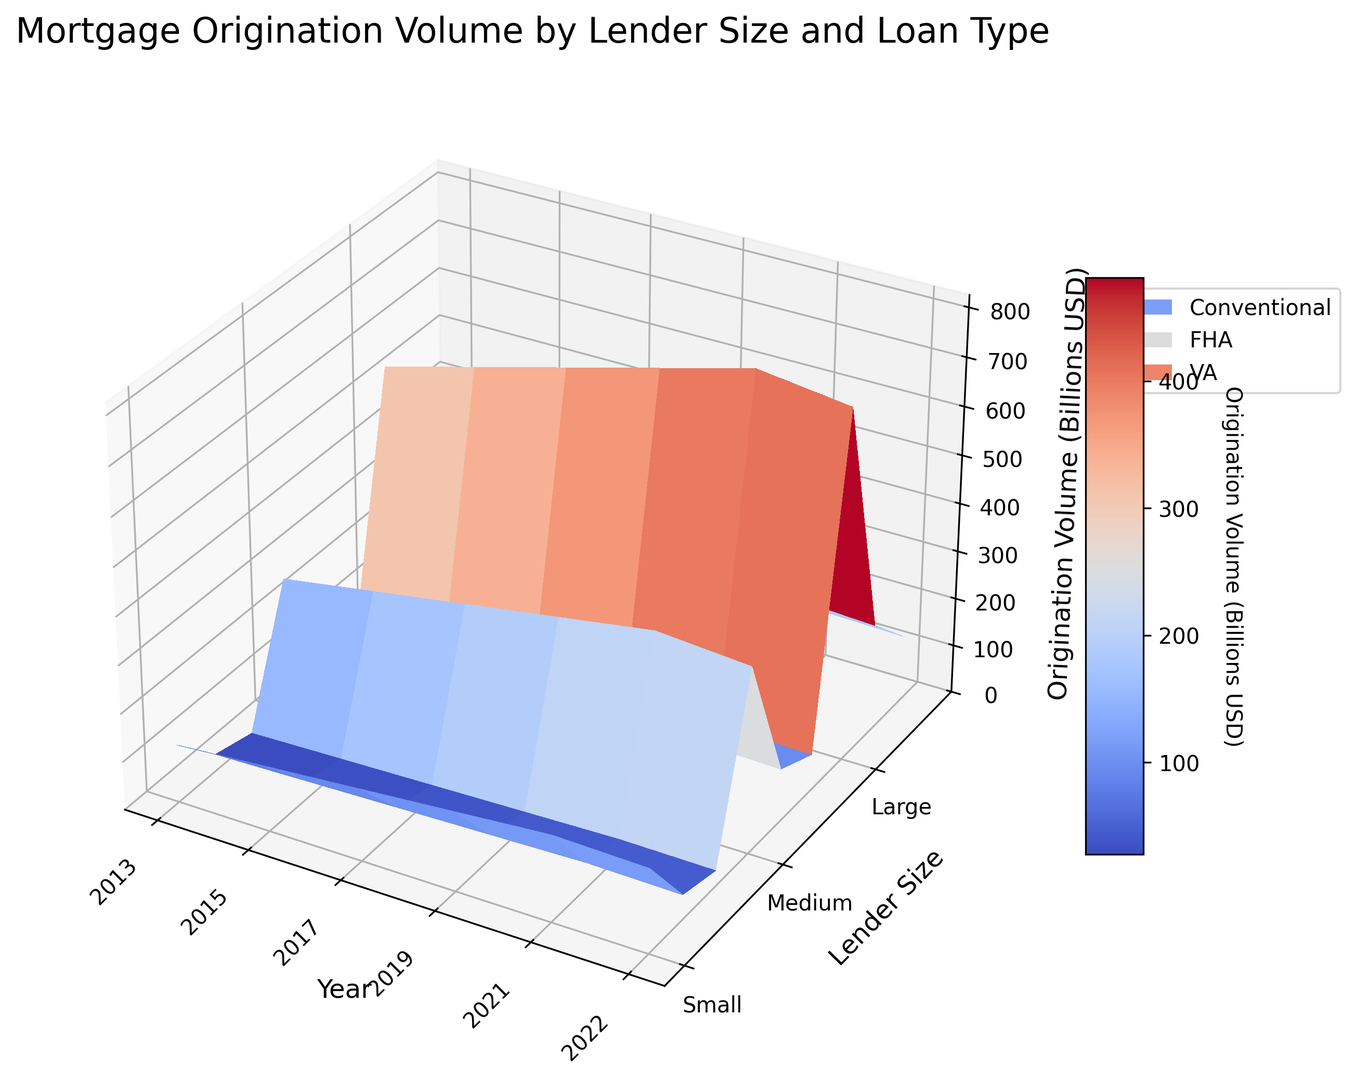What is the lender size category with the highest origination volume in 2013? Look at the figure for the year 2013. Observe the colors and heights of the 3D bars for each lender size to determine which is the highest. In 2013, "Large" lenders have the highest origination volume.
Answer: Large Which loan type shows the most significant increase in origination volume from 2013 to 2021 for medium lenders? First, observe the height of the 3D bars for medium lenders in 2013 for each loan type. Then, compare these to the heights in 2021 for the same loan types. The "Conventional" loan type shows the most significant increase.
Answer: Conventional What is the difference in origination volume between small and large lenders for VA loans in 2019? Check the 3D bars for VA loans in 2019 and note the heights for both small and large lenders. Subtract the height of the small lender bar from the height of the large lender bar. In 2019, the volumes are 30 (small) and 125 (large). Subtracting, 125 - 30 = 95 billion USD.
Answer: 95 billion USD Which year had the highest origination volume for FHA loans by large lenders? Look at the figure and observe the height of the 3D bars for each year for FHA loans by large lenders. Identify which bar is the tallest. The highest bar appears in 2021.
Answer: 2021 What is the average origination volume for Conventional loans by medium lenders across all years? To find the average, first sum the origination volumes for Conventional loans by medium lenders across all years. The volumes are 280, 310, 340, 370, 400, and 385. Summing these gives 2085. Divide this by the number of years (6). 2085 / 6 = 347.5 billion USD.
Answer: 347.5 billion USD 